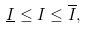Convert formula to latex. <formula><loc_0><loc_0><loc_500><loc_500>\underline { I } \leq I \leq \overline { I } ,</formula> 